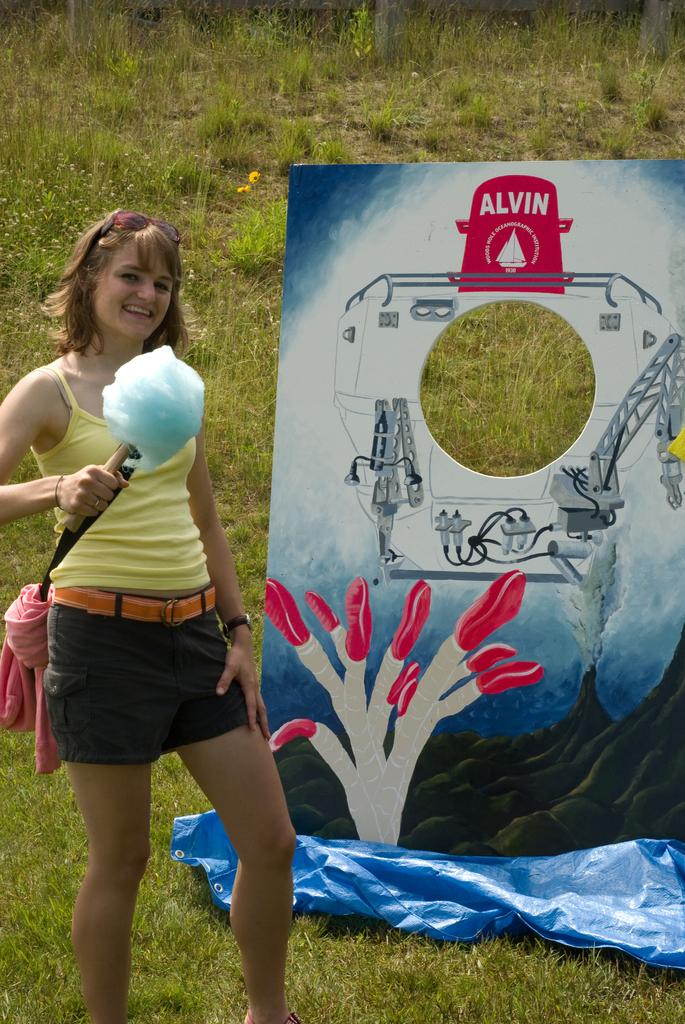What is the person in the image doing? The person is standing and smiling in the center of the image. What is the person holding in the image? The person is holding an object in the image. What can be seen in the background of the image? There is grass, a cloth, and a banner in the background of the image. What type of mint can be seen growing in the background of the image? There is no mint visible in the background of the image. How does the person perform a trick in the image? The image does not depict the person performing a trick. 